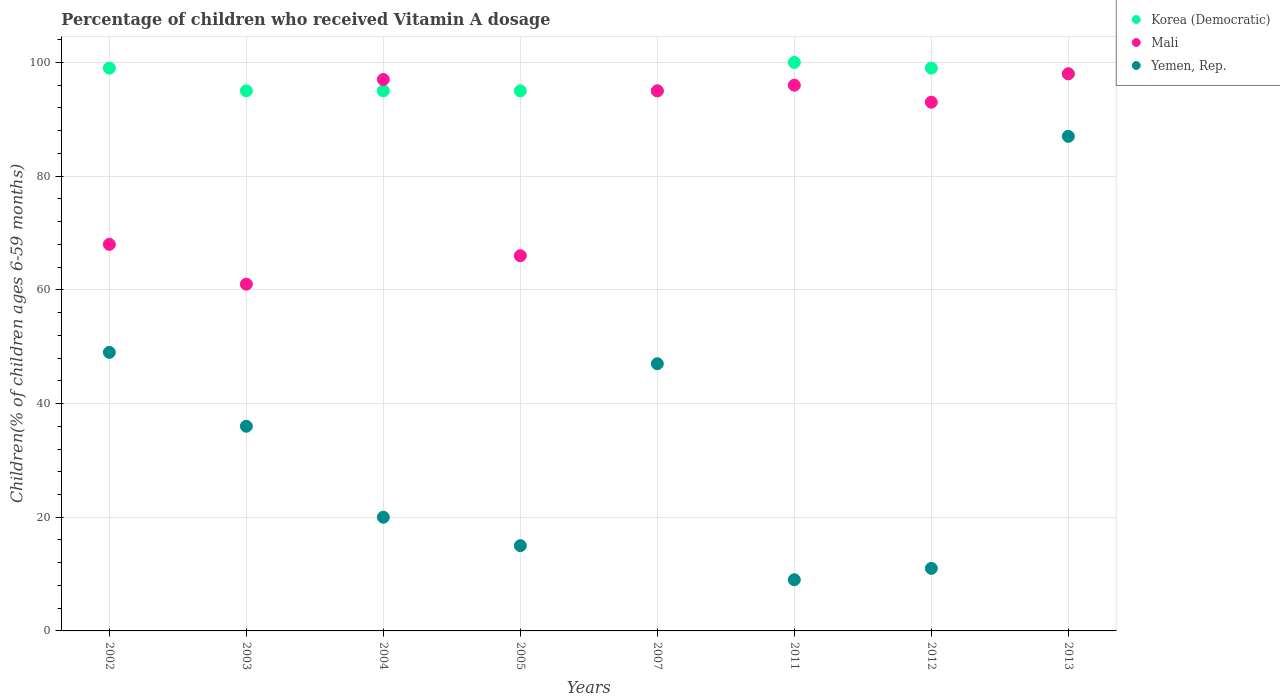How many different coloured dotlines are there?
Provide a short and direct response. 3. Is the number of dotlines equal to the number of legend labels?
Your answer should be compact. Yes. What is the percentage of children who received Vitamin A dosage in Korea (Democratic) in 2012?
Give a very brief answer. 99. In which year was the percentage of children who received Vitamin A dosage in Korea (Democratic) maximum?
Provide a succinct answer. 2011. In which year was the percentage of children who received Vitamin A dosage in Korea (Democratic) minimum?
Keep it short and to the point. 2003. What is the total percentage of children who received Vitamin A dosage in Yemen, Rep. in the graph?
Provide a succinct answer. 274. What is the difference between the percentage of children who received Vitamin A dosage in Yemen, Rep. in 2002 and that in 2007?
Offer a very short reply. 2. What is the difference between the percentage of children who received Vitamin A dosage in Yemen, Rep. in 2004 and the percentage of children who received Vitamin A dosage in Korea (Democratic) in 2002?
Ensure brevity in your answer.  -79. What is the average percentage of children who received Vitamin A dosage in Yemen, Rep. per year?
Provide a short and direct response. 34.25. In the year 2003, what is the difference between the percentage of children who received Vitamin A dosage in Korea (Democratic) and percentage of children who received Vitamin A dosage in Mali?
Your answer should be compact. 34. What is the ratio of the percentage of children who received Vitamin A dosage in Korea (Democratic) in 2005 to that in 2013?
Ensure brevity in your answer.  0.97. Is the percentage of children who received Vitamin A dosage in Yemen, Rep. in 2002 less than that in 2004?
Offer a very short reply. No. Is the difference between the percentage of children who received Vitamin A dosage in Korea (Democratic) in 2002 and 2013 greater than the difference between the percentage of children who received Vitamin A dosage in Mali in 2002 and 2013?
Provide a short and direct response. Yes. What is the difference between the highest and the lowest percentage of children who received Vitamin A dosage in Mali?
Ensure brevity in your answer.  37. In how many years, is the percentage of children who received Vitamin A dosage in Mali greater than the average percentage of children who received Vitamin A dosage in Mali taken over all years?
Offer a terse response. 5. Is the sum of the percentage of children who received Vitamin A dosage in Yemen, Rep. in 2011 and 2012 greater than the maximum percentage of children who received Vitamin A dosage in Korea (Democratic) across all years?
Offer a terse response. No. Is it the case that in every year, the sum of the percentage of children who received Vitamin A dosage in Korea (Democratic) and percentage of children who received Vitamin A dosage in Yemen, Rep.  is greater than the percentage of children who received Vitamin A dosage in Mali?
Your answer should be compact. Yes. Does the percentage of children who received Vitamin A dosage in Korea (Democratic) monotonically increase over the years?
Ensure brevity in your answer.  No. Is the percentage of children who received Vitamin A dosage in Korea (Democratic) strictly less than the percentage of children who received Vitamin A dosage in Mali over the years?
Provide a short and direct response. No. How many dotlines are there?
Provide a short and direct response. 3. How many years are there in the graph?
Keep it short and to the point. 8. What is the difference between two consecutive major ticks on the Y-axis?
Provide a short and direct response. 20. Are the values on the major ticks of Y-axis written in scientific E-notation?
Your response must be concise. No. Does the graph contain any zero values?
Offer a terse response. No. Where does the legend appear in the graph?
Keep it short and to the point. Top right. What is the title of the graph?
Your answer should be compact. Percentage of children who received Vitamin A dosage. What is the label or title of the Y-axis?
Your answer should be very brief. Children(% of children ages 6-59 months). What is the Children(% of children ages 6-59 months) in Yemen, Rep. in 2002?
Provide a short and direct response. 49. What is the Children(% of children ages 6-59 months) in Yemen, Rep. in 2003?
Give a very brief answer. 36. What is the Children(% of children ages 6-59 months) of Mali in 2004?
Offer a very short reply. 97. What is the Children(% of children ages 6-59 months) in Yemen, Rep. in 2004?
Your response must be concise. 20. What is the Children(% of children ages 6-59 months) of Korea (Democratic) in 2005?
Your answer should be compact. 95. What is the Children(% of children ages 6-59 months) of Yemen, Rep. in 2005?
Your response must be concise. 15. What is the Children(% of children ages 6-59 months) in Korea (Democratic) in 2007?
Your response must be concise. 95. What is the Children(% of children ages 6-59 months) of Mali in 2011?
Offer a very short reply. 96. What is the Children(% of children ages 6-59 months) in Korea (Democratic) in 2012?
Give a very brief answer. 99. What is the Children(% of children ages 6-59 months) of Mali in 2012?
Provide a short and direct response. 93. What is the Children(% of children ages 6-59 months) in Mali in 2013?
Keep it short and to the point. 98. Across all years, what is the maximum Children(% of children ages 6-59 months) of Korea (Democratic)?
Offer a terse response. 100. Across all years, what is the maximum Children(% of children ages 6-59 months) of Mali?
Your response must be concise. 98. Across all years, what is the minimum Children(% of children ages 6-59 months) of Korea (Democratic)?
Give a very brief answer. 95. Across all years, what is the minimum Children(% of children ages 6-59 months) in Yemen, Rep.?
Your response must be concise. 9. What is the total Children(% of children ages 6-59 months) of Korea (Democratic) in the graph?
Your answer should be compact. 776. What is the total Children(% of children ages 6-59 months) in Mali in the graph?
Provide a short and direct response. 674. What is the total Children(% of children ages 6-59 months) of Yemen, Rep. in the graph?
Make the answer very short. 274. What is the difference between the Children(% of children ages 6-59 months) in Korea (Democratic) in 2002 and that in 2003?
Your response must be concise. 4. What is the difference between the Children(% of children ages 6-59 months) of Mali in 2002 and that in 2003?
Your response must be concise. 7. What is the difference between the Children(% of children ages 6-59 months) of Korea (Democratic) in 2002 and that in 2004?
Provide a succinct answer. 4. What is the difference between the Children(% of children ages 6-59 months) in Korea (Democratic) in 2002 and that in 2005?
Keep it short and to the point. 4. What is the difference between the Children(% of children ages 6-59 months) in Yemen, Rep. in 2002 and that in 2005?
Offer a terse response. 34. What is the difference between the Children(% of children ages 6-59 months) in Mali in 2002 and that in 2007?
Ensure brevity in your answer.  -27. What is the difference between the Children(% of children ages 6-59 months) of Yemen, Rep. in 2002 and that in 2007?
Your response must be concise. 2. What is the difference between the Children(% of children ages 6-59 months) in Yemen, Rep. in 2002 and that in 2011?
Provide a short and direct response. 40. What is the difference between the Children(% of children ages 6-59 months) of Mali in 2002 and that in 2012?
Offer a very short reply. -25. What is the difference between the Children(% of children ages 6-59 months) in Korea (Democratic) in 2002 and that in 2013?
Provide a succinct answer. 1. What is the difference between the Children(% of children ages 6-59 months) in Mali in 2002 and that in 2013?
Provide a succinct answer. -30. What is the difference between the Children(% of children ages 6-59 months) of Yemen, Rep. in 2002 and that in 2013?
Give a very brief answer. -38. What is the difference between the Children(% of children ages 6-59 months) in Mali in 2003 and that in 2004?
Offer a very short reply. -36. What is the difference between the Children(% of children ages 6-59 months) of Yemen, Rep. in 2003 and that in 2005?
Your response must be concise. 21. What is the difference between the Children(% of children ages 6-59 months) in Korea (Democratic) in 2003 and that in 2007?
Give a very brief answer. 0. What is the difference between the Children(% of children ages 6-59 months) in Mali in 2003 and that in 2007?
Give a very brief answer. -34. What is the difference between the Children(% of children ages 6-59 months) in Yemen, Rep. in 2003 and that in 2007?
Provide a succinct answer. -11. What is the difference between the Children(% of children ages 6-59 months) of Korea (Democratic) in 2003 and that in 2011?
Your answer should be compact. -5. What is the difference between the Children(% of children ages 6-59 months) in Mali in 2003 and that in 2011?
Your answer should be very brief. -35. What is the difference between the Children(% of children ages 6-59 months) in Mali in 2003 and that in 2012?
Offer a very short reply. -32. What is the difference between the Children(% of children ages 6-59 months) of Mali in 2003 and that in 2013?
Provide a short and direct response. -37. What is the difference between the Children(% of children ages 6-59 months) in Yemen, Rep. in 2003 and that in 2013?
Your answer should be compact. -51. What is the difference between the Children(% of children ages 6-59 months) of Yemen, Rep. in 2004 and that in 2005?
Your answer should be compact. 5. What is the difference between the Children(% of children ages 6-59 months) in Korea (Democratic) in 2004 and that in 2011?
Provide a succinct answer. -5. What is the difference between the Children(% of children ages 6-59 months) of Mali in 2004 and that in 2011?
Provide a succinct answer. 1. What is the difference between the Children(% of children ages 6-59 months) in Korea (Democratic) in 2004 and that in 2012?
Offer a very short reply. -4. What is the difference between the Children(% of children ages 6-59 months) of Mali in 2004 and that in 2012?
Provide a short and direct response. 4. What is the difference between the Children(% of children ages 6-59 months) in Yemen, Rep. in 2004 and that in 2013?
Make the answer very short. -67. What is the difference between the Children(% of children ages 6-59 months) in Korea (Democratic) in 2005 and that in 2007?
Offer a terse response. 0. What is the difference between the Children(% of children ages 6-59 months) of Mali in 2005 and that in 2007?
Provide a succinct answer. -29. What is the difference between the Children(% of children ages 6-59 months) in Yemen, Rep. in 2005 and that in 2007?
Offer a very short reply. -32. What is the difference between the Children(% of children ages 6-59 months) in Yemen, Rep. in 2005 and that in 2011?
Provide a succinct answer. 6. What is the difference between the Children(% of children ages 6-59 months) of Korea (Democratic) in 2005 and that in 2012?
Offer a terse response. -4. What is the difference between the Children(% of children ages 6-59 months) of Mali in 2005 and that in 2012?
Offer a terse response. -27. What is the difference between the Children(% of children ages 6-59 months) of Korea (Democratic) in 2005 and that in 2013?
Make the answer very short. -3. What is the difference between the Children(% of children ages 6-59 months) in Mali in 2005 and that in 2013?
Offer a terse response. -32. What is the difference between the Children(% of children ages 6-59 months) of Yemen, Rep. in 2005 and that in 2013?
Keep it short and to the point. -72. What is the difference between the Children(% of children ages 6-59 months) of Korea (Democratic) in 2007 and that in 2011?
Your answer should be very brief. -5. What is the difference between the Children(% of children ages 6-59 months) in Mali in 2007 and that in 2011?
Keep it short and to the point. -1. What is the difference between the Children(% of children ages 6-59 months) in Mali in 2007 and that in 2012?
Make the answer very short. 2. What is the difference between the Children(% of children ages 6-59 months) of Yemen, Rep. in 2007 and that in 2012?
Your response must be concise. 36. What is the difference between the Children(% of children ages 6-59 months) of Yemen, Rep. in 2007 and that in 2013?
Offer a terse response. -40. What is the difference between the Children(% of children ages 6-59 months) of Mali in 2011 and that in 2012?
Provide a succinct answer. 3. What is the difference between the Children(% of children ages 6-59 months) of Yemen, Rep. in 2011 and that in 2013?
Provide a short and direct response. -78. What is the difference between the Children(% of children ages 6-59 months) of Mali in 2012 and that in 2013?
Your answer should be very brief. -5. What is the difference between the Children(% of children ages 6-59 months) of Yemen, Rep. in 2012 and that in 2013?
Offer a very short reply. -76. What is the difference between the Children(% of children ages 6-59 months) in Korea (Democratic) in 2002 and the Children(% of children ages 6-59 months) in Yemen, Rep. in 2003?
Provide a short and direct response. 63. What is the difference between the Children(% of children ages 6-59 months) of Mali in 2002 and the Children(% of children ages 6-59 months) of Yemen, Rep. in 2003?
Provide a short and direct response. 32. What is the difference between the Children(% of children ages 6-59 months) in Korea (Democratic) in 2002 and the Children(% of children ages 6-59 months) in Mali in 2004?
Give a very brief answer. 2. What is the difference between the Children(% of children ages 6-59 months) of Korea (Democratic) in 2002 and the Children(% of children ages 6-59 months) of Yemen, Rep. in 2004?
Your answer should be compact. 79. What is the difference between the Children(% of children ages 6-59 months) of Mali in 2002 and the Children(% of children ages 6-59 months) of Yemen, Rep. in 2004?
Provide a succinct answer. 48. What is the difference between the Children(% of children ages 6-59 months) in Korea (Democratic) in 2002 and the Children(% of children ages 6-59 months) in Yemen, Rep. in 2005?
Your answer should be very brief. 84. What is the difference between the Children(% of children ages 6-59 months) in Mali in 2002 and the Children(% of children ages 6-59 months) in Yemen, Rep. in 2005?
Offer a terse response. 53. What is the difference between the Children(% of children ages 6-59 months) of Mali in 2002 and the Children(% of children ages 6-59 months) of Yemen, Rep. in 2007?
Keep it short and to the point. 21. What is the difference between the Children(% of children ages 6-59 months) in Korea (Democratic) in 2002 and the Children(% of children ages 6-59 months) in Yemen, Rep. in 2011?
Offer a very short reply. 90. What is the difference between the Children(% of children ages 6-59 months) in Mali in 2002 and the Children(% of children ages 6-59 months) in Yemen, Rep. in 2011?
Provide a short and direct response. 59. What is the difference between the Children(% of children ages 6-59 months) of Korea (Democratic) in 2002 and the Children(% of children ages 6-59 months) of Mali in 2012?
Your answer should be compact. 6. What is the difference between the Children(% of children ages 6-59 months) of Korea (Democratic) in 2002 and the Children(% of children ages 6-59 months) of Yemen, Rep. in 2013?
Offer a terse response. 12. What is the difference between the Children(% of children ages 6-59 months) in Mali in 2002 and the Children(% of children ages 6-59 months) in Yemen, Rep. in 2013?
Your response must be concise. -19. What is the difference between the Children(% of children ages 6-59 months) of Korea (Democratic) in 2003 and the Children(% of children ages 6-59 months) of Yemen, Rep. in 2005?
Give a very brief answer. 80. What is the difference between the Children(% of children ages 6-59 months) of Mali in 2003 and the Children(% of children ages 6-59 months) of Yemen, Rep. in 2005?
Offer a terse response. 46. What is the difference between the Children(% of children ages 6-59 months) of Korea (Democratic) in 2003 and the Children(% of children ages 6-59 months) of Yemen, Rep. in 2007?
Keep it short and to the point. 48. What is the difference between the Children(% of children ages 6-59 months) in Mali in 2003 and the Children(% of children ages 6-59 months) in Yemen, Rep. in 2007?
Provide a short and direct response. 14. What is the difference between the Children(% of children ages 6-59 months) of Korea (Democratic) in 2003 and the Children(% of children ages 6-59 months) of Yemen, Rep. in 2011?
Make the answer very short. 86. What is the difference between the Children(% of children ages 6-59 months) of Korea (Democratic) in 2003 and the Children(% of children ages 6-59 months) of Mali in 2012?
Provide a succinct answer. 2. What is the difference between the Children(% of children ages 6-59 months) of Mali in 2003 and the Children(% of children ages 6-59 months) of Yemen, Rep. in 2012?
Offer a terse response. 50. What is the difference between the Children(% of children ages 6-59 months) of Mali in 2003 and the Children(% of children ages 6-59 months) of Yemen, Rep. in 2013?
Make the answer very short. -26. What is the difference between the Children(% of children ages 6-59 months) of Korea (Democratic) in 2004 and the Children(% of children ages 6-59 months) of Yemen, Rep. in 2007?
Provide a short and direct response. 48. What is the difference between the Children(% of children ages 6-59 months) in Korea (Democratic) in 2004 and the Children(% of children ages 6-59 months) in Mali in 2011?
Ensure brevity in your answer.  -1. What is the difference between the Children(% of children ages 6-59 months) in Korea (Democratic) in 2004 and the Children(% of children ages 6-59 months) in Yemen, Rep. in 2011?
Provide a succinct answer. 86. What is the difference between the Children(% of children ages 6-59 months) in Korea (Democratic) in 2004 and the Children(% of children ages 6-59 months) in Mali in 2012?
Make the answer very short. 2. What is the difference between the Children(% of children ages 6-59 months) in Korea (Democratic) in 2004 and the Children(% of children ages 6-59 months) in Mali in 2013?
Provide a succinct answer. -3. What is the difference between the Children(% of children ages 6-59 months) in Mali in 2004 and the Children(% of children ages 6-59 months) in Yemen, Rep. in 2013?
Your response must be concise. 10. What is the difference between the Children(% of children ages 6-59 months) of Korea (Democratic) in 2005 and the Children(% of children ages 6-59 months) of Mali in 2011?
Provide a short and direct response. -1. What is the difference between the Children(% of children ages 6-59 months) in Mali in 2005 and the Children(% of children ages 6-59 months) in Yemen, Rep. in 2011?
Offer a terse response. 57. What is the difference between the Children(% of children ages 6-59 months) in Korea (Democratic) in 2005 and the Children(% of children ages 6-59 months) in Yemen, Rep. in 2013?
Offer a very short reply. 8. What is the difference between the Children(% of children ages 6-59 months) of Mali in 2005 and the Children(% of children ages 6-59 months) of Yemen, Rep. in 2013?
Your response must be concise. -21. What is the difference between the Children(% of children ages 6-59 months) of Korea (Democratic) in 2007 and the Children(% of children ages 6-59 months) of Mali in 2011?
Provide a short and direct response. -1. What is the difference between the Children(% of children ages 6-59 months) of Korea (Democratic) in 2007 and the Children(% of children ages 6-59 months) of Yemen, Rep. in 2011?
Your response must be concise. 86. What is the difference between the Children(% of children ages 6-59 months) in Korea (Democratic) in 2007 and the Children(% of children ages 6-59 months) in Yemen, Rep. in 2012?
Give a very brief answer. 84. What is the difference between the Children(% of children ages 6-59 months) of Mali in 2007 and the Children(% of children ages 6-59 months) of Yemen, Rep. in 2012?
Your answer should be compact. 84. What is the difference between the Children(% of children ages 6-59 months) of Korea (Democratic) in 2007 and the Children(% of children ages 6-59 months) of Mali in 2013?
Your answer should be compact. -3. What is the difference between the Children(% of children ages 6-59 months) of Korea (Democratic) in 2007 and the Children(% of children ages 6-59 months) of Yemen, Rep. in 2013?
Give a very brief answer. 8. What is the difference between the Children(% of children ages 6-59 months) of Korea (Democratic) in 2011 and the Children(% of children ages 6-59 months) of Yemen, Rep. in 2012?
Give a very brief answer. 89. What is the difference between the Children(% of children ages 6-59 months) of Mali in 2011 and the Children(% of children ages 6-59 months) of Yemen, Rep. in 2012?
Provide a short and direct response. 85. What is the difference between the Children(% of children ages 6-59 months) in Korea (Democratic) in 2011 and the Children(% of children ages 6-59 months) in Yemen, Rep. in 2013?
Offer a terse response. 13. What is the difference between the Children(% of children ages 6-59 months) in Mali in 2011 and the Children(% of children ages 6-59 months) in Yemen, Rep. in 2013?
Offer a very short reply. 9. What is the difference between the Children(% of children ages 6-59 months) in Korea (Democratic) in 2012 and the Children(% of children ages 6-59 months) in Yemen, Rep. in 2013?
Ensure brevity in your answer.  12. What is the difference between the Children(% of children ages 6-59 months) in Mali in 2012 and the Children(% of children ages 6-59 months) in Yemen, Rep. in 2013?
Offer a very short reply. 6. What is the average Children(% of children ages 6-59 months) of Korea (Democratic) per year?
Make the answer very short. 97. What is the average Children(% of children ages 6-59 months) in Mali per year?
Your answer should be very brief. 84.25. What is the average Children(% of children ages 6-59 months) of Yemen, Rep. per year?
Give a very brief answer. 34.25. In the year 2002, what is the difference between the Children(% of children ages 6-59 months) in Mali and Children(% of children ages 6-59 months) in Yemen, Rep.?
Offer a very short reply. 19. In the year 2003, what is the difference between the Children(% of children ages 6-59 months) of Korea (Democratic) and Children(% of children ages 6-59 months) of Yemen, Rep.?
Provide a succinct answer. 59. In the year 2004, what is the difference between the Children(% of children ages 6-59 months) in Mali and Children(% of children ages 6-59 months) in Yemen, Rep.?
Offer a terse response. 77. In the year 2005, what is the difference between the Children(% of children ages 6-59 months) in Korea (Democratic) and Children(% of children ages 6-59 months) in Mali?
Offer a terse response. 29. In the year 2011, what is the difference between the Children(% of children ages 6-59 months) of Korea (Democratic) and Children(% of children ages 6-59 months) of Mali?
Your answer should be very brief. 4. In the year 2011, what is the difference between the Children(% of children ages 6-59 months) in Korea (Democratic) and Children(% of children ages 6-59 months) in Yemen, Rep.?
Make the answer very short. 91. In the year 2012, what is the difference between the Children(% of children ages 6-59 months) of Korea (Democratic) and Children(% of children ages 6-59 months) of Yemen, Rep.?
Your answer should be compact. 88. In the year 2013, what is the difference between the Children(% of children ages 6-59 months) of Korea (Democratic) and Children(% of children ages 6-59 months) of Yemen, Rep.?
Offer a terse response. 11. In the year 2013, what is the difference between the Children(% of children ages 6-59 months) in Mali and Children(% of children ages 6-59 months) in Yemen, Rep.?
Provide a short and direct response. 11. What is the ratio of the Children(% of children ages 6-59 months) in Korea (Democratic) in 2002 to that in 2003?
Offer a very short reply. 1.04. What is the ratio of the Children(% of children ages 6-59 months) of Mali in 2002 to that in 2003?
Offer a terse response. 1.11. What is the ratio of the Children(% of children ages 6-59 months) of Yemen, Rep. in 2002 to that in 2003?
Your answer should be compact. 1.36. What is the ratio of the Children(% of children ages 6-59 months) of Korea (Democratic) in 2002 to that in 2004?
Keep it short and to the point. 1.04. What is the ratio of the Children(% of children ages 6-59 months) in Mali in 2002 to that in 2004?
Keep it short and to the point. 0.7. What is the ratio of the Children(% of children ages 6-59 months) of Yemen, Rep. in 2002 to that in 2004?
Offer a very short reply. 2.45. What is the ratio of the Children(% of children ages 6-59 months) of Korea (Democratic) in 2002 to that in 2005?
Your answer should be very brief. 1.04. What is the ratio of the Children(% of children ages 6-59 months) in Mali in 2002 to that in 2005?
Your answer should be very brief. 1.03. What is the ratio of the Children(% of children ages 6-59 months) in Yemen, Rep. in 2002 to that in 2005?
Ensure brevity in your answer.  3.27. What is the ratio of the Children(% of children ages 6-59 months) in Korea (Democratic) in 2002 to that in 2007?
Your response must be concise. 1.04. What is the ratio of the Children(% of children ages 6-59 months) in Mali in 2002 to that in 2007?
Provide a succinct answer. 0.72. What is the ratio of the Children(% of children ages 6-59 months) of Yemen, Rep. in 2002 to that in 2007?
Your response must be concise. 1.04. What is the ratio of the Children(% of children ages 6-59 months) of Korea (Democratic) in 2002 to that in 2011?
Offer a very short reply. 0.99. What is the ratio of the Children(% of children ages 6-59 months) of Mali in 2002 to that in 2011?
Give a very brief answer. 0.71. What is the ratio of the Children(% of children ages 6-59 months) of Yemen, Rep. in 2002 to that in 2011?
Offer a terse response. 5.44. What is the ratio of the Children(% of children ages 6-59 months) in Korea (Democratic) in 2002 to that in 2012?
Give a very brief answer. 1. What is the ratio of the Children(% of children ages 6-59 months) of Mali in 2002 to that in 2012?
Your answer should be compact. 0.73. What is the ratio of the Children(% of children ages 6-59 months) in Yemen, Rep. in 2002 to that in 2012?
Provide a short and direct response. 4.45. What is the ratio of the Children(% of children ages 6-59 months) in Korea (Democratic) in 2002 to that in 2013?
Provide a succinct answer. 1.01. What is the ratio of the Children(% of children ages 6-59 months) in Mali in 2002 to that in 2013?
Your response must be concise. 0.69. What is the ratio of the Children(% of children ages 6-59 months) of Yemen, Rep. in 2002 to that in 2013?
Provide a succinct answer. 0.56. What is the ratio of the Children(% of children ages 6-59 months) in Mali in 2003 to that in 2004?
Your answer should be very brief. 0.63. What is the ratio of the Children(% of children ages 6-59 months) of Yemen, Rep. in 2003 to that in 2004?
Provide a short and direct response. 1.8. What is the ratio of the Children(% of children ages 6-59 months) of Mali in 2003 to that in 2005?
Your answer should be compact. 0.92. What is the ratio of the Children(% of children ages 6-59 months) of Korea (Democratic) in 2003 to that in 2007?
Ensure brevity in your answer.  1. What is the ratio of the Children(% of children ages 6-59 months) of Mali in 2003 to that in 2007?
Ensure brevity in your answer.  0.64. What is the ratio of the Children(% of children ages 6-59 months) in Yemen, Rep. in 2003 to that in 2007?
Ensure brevity in your answer.  0.77. What is the ratio of the Children(% of children ages 6-59 months) of Mali in 2003 to that in 2011?
Keep it short and to the point. 0.64. What is the ratio of the Children(% of children ages 6-59 months) of Korea (Democratic) in 2003 to that in 2012?
Ensure brevity in your answer.  0.96. What is the ratio of the Children(% of children ages 6-59 months) in Mali in 2003 to that in 2012?
Make the answer very short. 0.66. What is the ratio of the Children(% of children ages 6-59 months) in Yemen, Rep. in 2003 to that in 2012?
Keep it short and to the point. 3.27. What is the ratio of the Children(% of children ages 6-59 months) of Korea (Democratic) in 2003 to that in 2013?
Your answer should be very brief. 0.97. What is the ratio of the Children(% of children ages 6-59 months) in Mali in 2003 to that in 2013?
Make the answer very short. 0.62. What is the ratio of the Children(% of children ages 6-59 months) of Yemen, Rep. in 2003 to that in 2013?
Offer a very short reply. 0.41. What is the ratio of the Children(% of children ages 6-59 months) in Korea (Democratic) in 2004 to that in 2005?
Ensure brevity in your answer.  1. What is the ratio of the Children(% of children ages 6-59 months) in Mali in 2004 to that in 2005?
Your response must be concise. 1.47. What is the ratio of the Children(% of children ages 6-59 months) of Yemen, Rep. in 2004 to that in 2005?
Offer a very short reply. 1.33. What is the ratio of the Children(% of children ages 6-59 months) in Mali in 2004 to that in 2007?
Give a very brief answer. 1.02. What is the ratio of the Children(% of children ages 6-59 months) of Yemen, Rep. in 2004 to that in 2007?
Make the answer very short. 0.43. What is the ratio of the Children(% of children ages 6-59 months) of Mali in 2004 to that in 2011?
Provide a succinct answer. 1.01. What is the ratio of the Children(% of children ages 6-59 months) of Yemen, Rep. in 2004 to that in 2011?
Provide a succinct answer. 2.22. What is the ratio of the Children(% of children ages 6-59 months) in Korea (Democratic) in 2004 to that in 2012?
Your answer should be very brief. 0.96. What is the ratio of the Children(% of children ages 6-59 months) of Mali in 2004 to that in 2012?
Keep it short and to the point. 1.04. What is the ratio of the Children(% of children ages 6-59 months) of Yemen, Rep. in 2004 to that in 2012?
Provide a succinct answer. 1.82. What is the ratio of the Children(% of children ages 6-59 months) of Korea (Democratic) in 2004 to that in 2013?
Your answer should be very brief. 0.97. What is the ratio of the Children(% of children ages 6-59 months) in Yemen, Rep. in 2004 to that in 2013?
Offer a very short reply. 0.23. What is the ratio of the Children(% of children ages 6-59 months) of Mali in 2005 to that in 2007?
Provide a succinct answer. 0.69. What is the ratio of the Children(% of children ages 6-59 months) in Yemen, Rep. in 2005 to that in 2007?
Provide a succinct answer. 0.32. What is the ratio of the Children(% of children ages 6-59 months) in Korea (Democratic) in 2005 to that in 2011?
Provide a succinct answer. 0.95. What is the ratio of the Children(% of children ages 6-59 months) in Mali in 2005 to that in 2011?
Your answer should be compact. 0.69. What is the ratio of the Children(% of children ages 6-59 months) of Yemen, Rep. in 2005 to that in 2011?
Provide a short and direct response. 1.67. What is the ratio of the Children(% of children ages 6-59 months) of Korea (Democratic) in 2005 to that in 2012?
Make the answer very short. 0.96. What is the ratio of the Children(% of children ages 6-59 months) in Mali in 2005 to that in 2012?
Keep it short and to the point. 0.71. What is the ratio of the Children(% of children ages 6-59 months) in Yemen, Rep. in 2005 to that in 2012?
Provide a short and direct response. 1.36. What is the ratio of the Children(% of children ages 6-59 months) in Korea (Democratic) in 2005 to that in 2013?
Offer a very short reply. 0.97. What is the ratio of the Children(% of children ages 6-59 months) in Mali in 2005 to that in 2013?
Keep it short and to the point. 0.67. What is the ratio of the Children(% of children ages 6-59 months) of Yemen, Rep. in 2005 to that in 2013?
Your answer should be very brief. 0.17. What is the ratio of the Children(% of children ages 6-59 months) in Yemen, Rep. in 2007 to that in 2011?
Ensure brevity in your answer.  5.22. What is the ratio of the Children(% of children ages 6-59 months) of Korea (Democratic) in 2007 to that in 2012?
Offer a terse response. 0.96. What is the ratio of the Children(% of children ages 6-59 months) in Mali in 2007 to that in 2012?
Your answer should be compact. 1.02. What is the ratio of the Children(% of children ages 6-59 months) in Yemen, Rep. in 2007 to that in 2012?
Offer a very short reply. 4.27. What is the ratio of the Children(% of children ages 6-59 months) in Korea (Democratic) in 2007 to that in 2013?
Ensure brevity in your answer.  0.97. What is the ratio of the Children(% of children ages 6-59 months) of Mali in 2007 to that in 2013?
Provide a short and direct response. 0.97. What is the ratio of the Children(% of children ages 6-59 months) of Yemen, Rep. in 2007 to that in 2013?
Make the answer very short. 0.54. What is the ratio of the Children(% of children ages 6-59 months) of Korea (Democratic) in 2011 to that in 2012?
Your answer should be compact. 1.01. What is the ratio of the Children(% of children ages 6-59 months) in Mali in 2011 to that in 2012?
Provide a short and direct response. 1.03. What is the ratio of the Children(% of children ages 6-59 months) in Yemen, Rep. in 2011 to that in 2012?
Offer a very short reply. 0.82. What is the ratio of the Children(% of children ages 6-59 months) of Korea (Democratic) in 2011 to that in 2013?
Ensure brevity in your answer.  1.02. What is the ratio of the Children(% of children ages 6-59 months) of Mali in 2011 to that in 2013?
Provide a short and direct response. 0.98. What is the ratio of the Children(% of children ages 6-59 months) in Yemen, Rep. in 2011 to that in 2013?
Your answer should be compact. 0.1. What is the ratio of the Children(% of children ages 6-59 months) in Korea (Democratic) in 2012 to that in 2013?
Keep it short and to the point. 1.01. What is the ratio of the Children(% of children ages 6-59 months) in Mali in 2012 to that in 2013?
Provide a succinct answer. 0.95. What is the ratio of the Children(% of children ages 6-59 months) of Yemen, Rep. in 2012 to that in 2013?
Offer a terse response. 0.13. What is the difference between the highest and the second highest Children(% of children ages 6-59 months) of Korea (Democratic)?
Give a very brief answer. 1. What is the difference between the highest and the second highest Children(% of children ages 6-59 months) of Yemen, Rep.?
Provide a short and direct response. 38. What is the difference between the highest and the lowest Children(% of children ages 6-59 months) of Mali?
Your response must be concise. 37. 